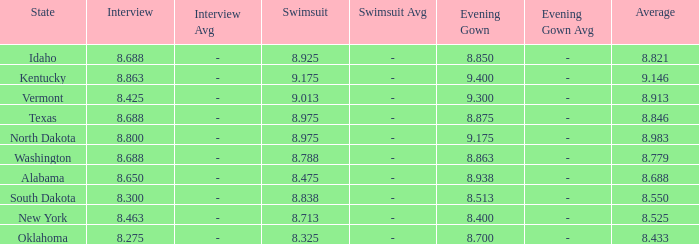What is the average interview score from Kentucky? 8.863. 